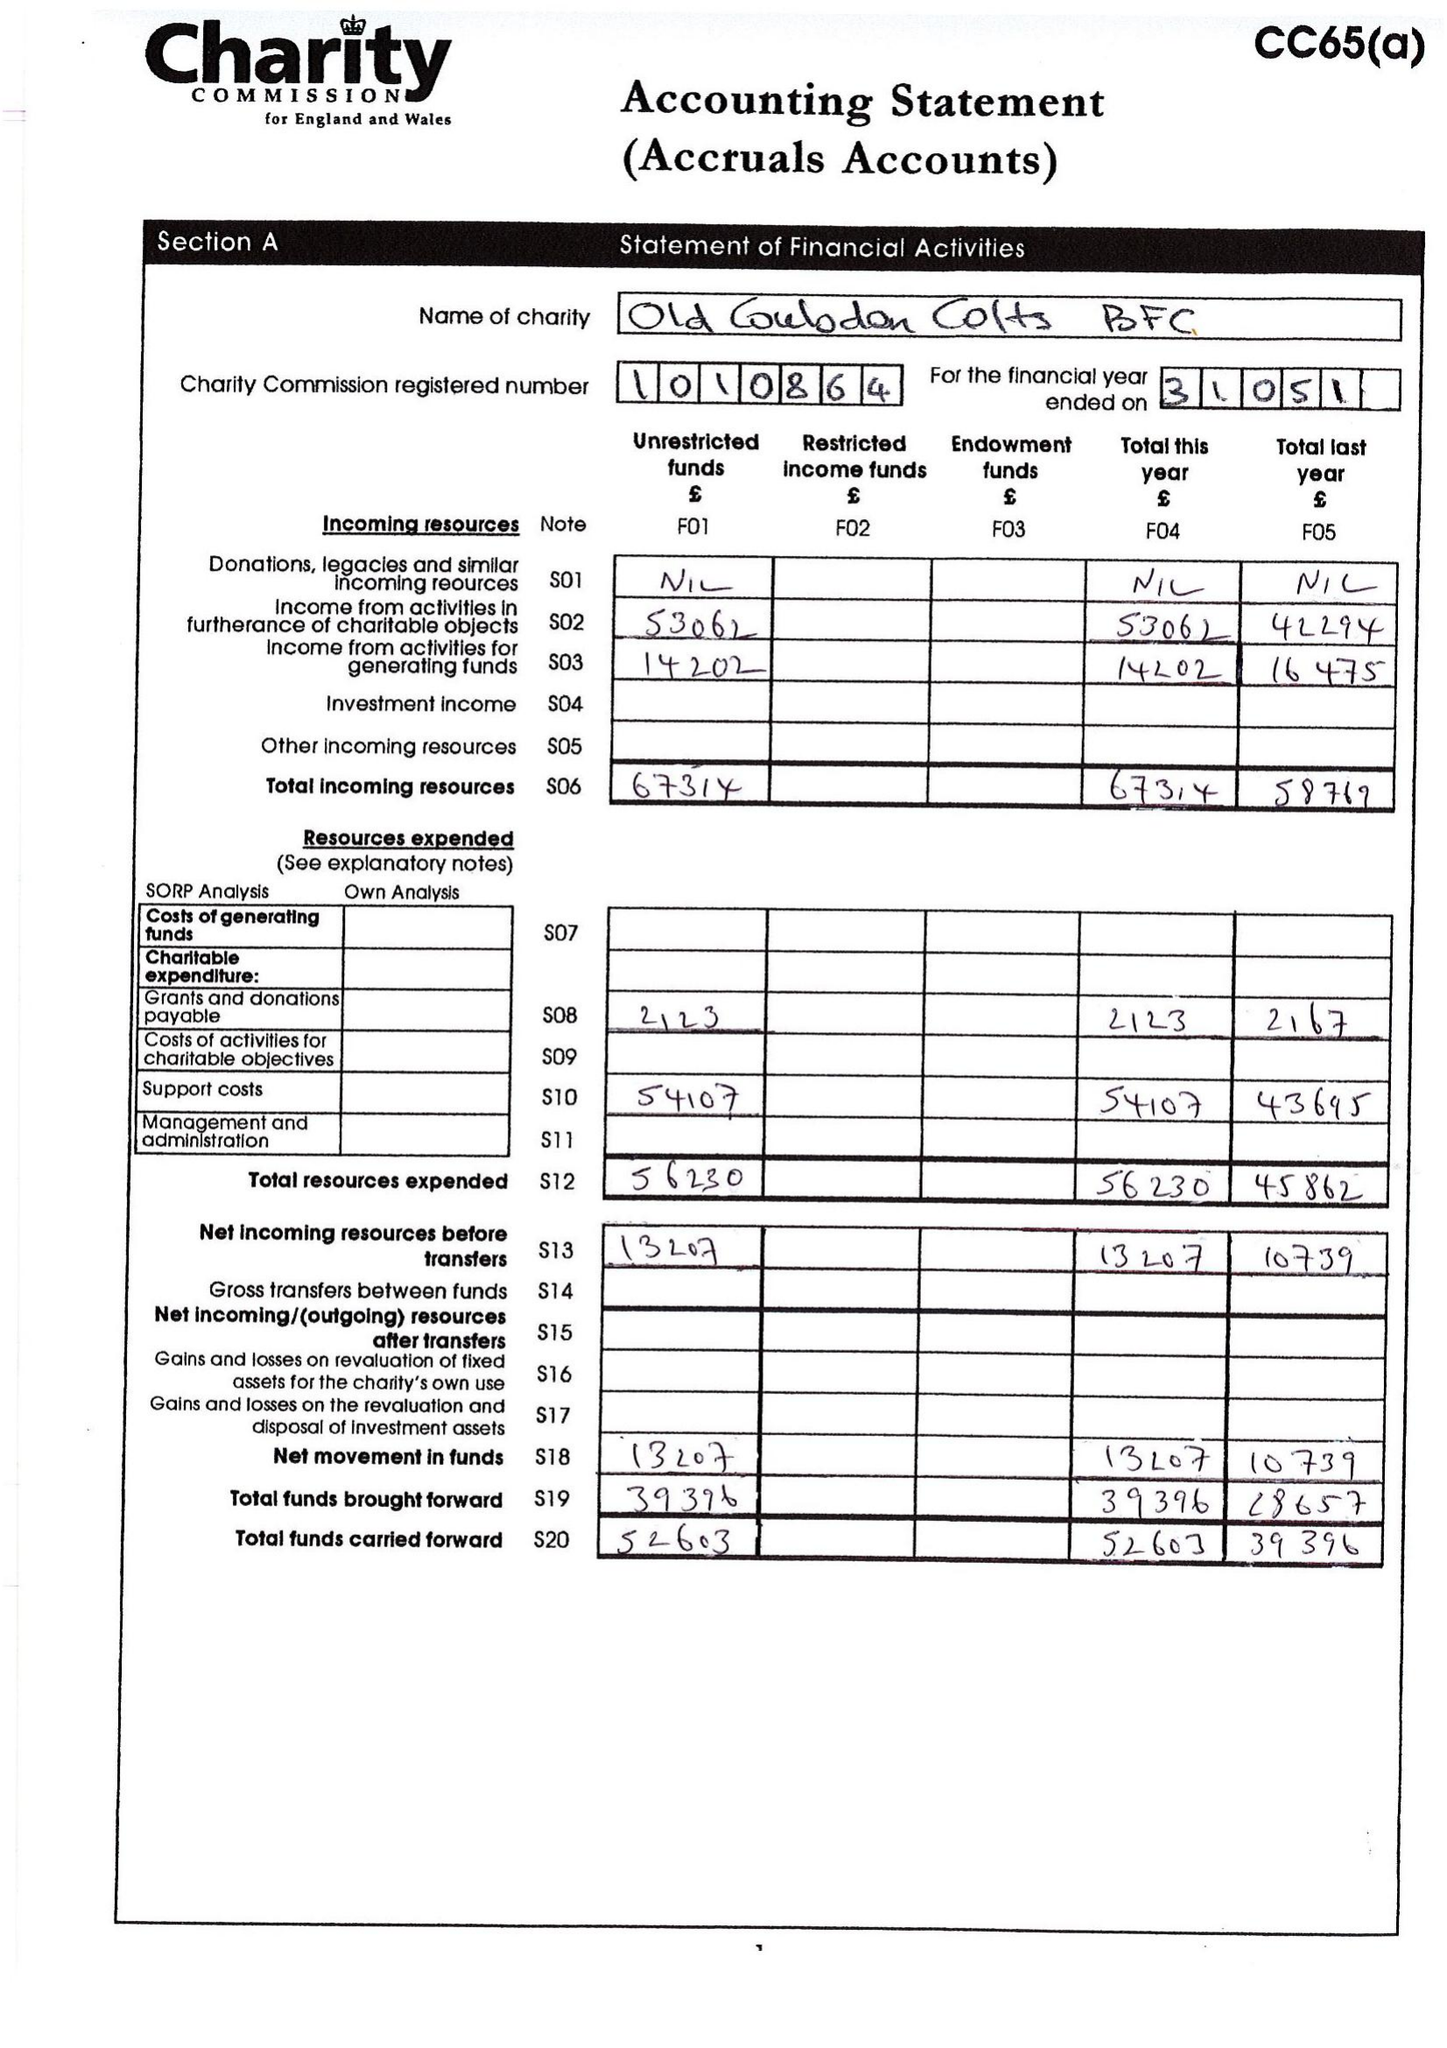What is the value for the charity_name?
Answer the question using a single word or phrase. Old Coulsdon Colts Bfc 